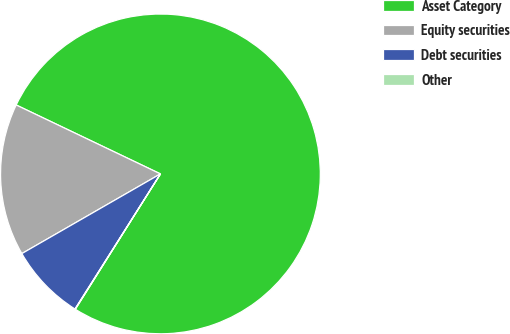Convert chart. <chart><loc_0><loc_0><loc_500><loc_500><pie_chart><fcel>Asset Category<fcel>Equity securities<fcel>Debt securities<fcel>Other<nl><fcel>76.84%<fcel>15.4%<fcel>7.72%<fcel>0.04%<nl></chart> 